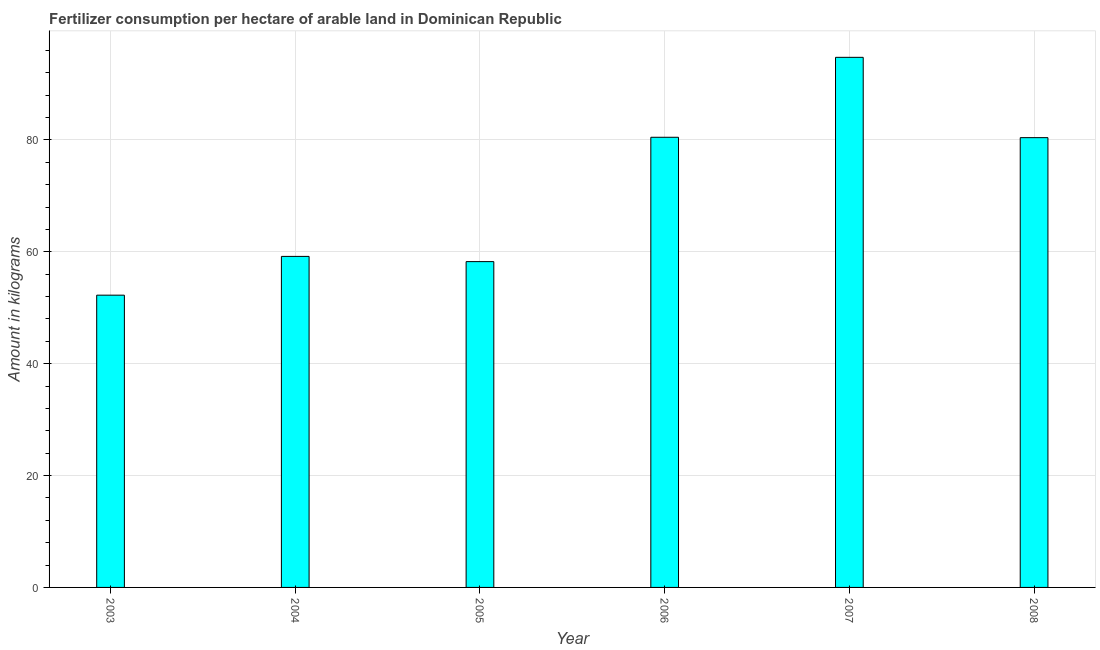What is the title of the graph?
Give a very brief answer. Fertilizer consumption per hectare of arable land in Dominican Republic . What is the label or title of the Y-axis?
Keep it short and to the point. Amount in kilograms. What is the amount of fertilizer consumption in 2008?
Provide a succinct answer. 80.4. Across all years, what is the maximum amount of fertilizer consumption?
Offer a very short reply. 94.76. Across all years, what is the minimum amount of fertilizer consumption?
Your answer should be compact. 52.24. In which year was the amount of fertilizer consumption maximum?
Keep it short and to the point. 2007. In which year was the amount of fertilizer consumption minimum?
Offer a terse response. 2003. What is the sum of the amount of fertilizer consumption?
Offer a terse response. 425.28. What is the difference between the amount of fertilizer consumption in 2007 and 2008?
Your response must be concise. 14.36. What is the average amount of fertilizer consumption per year?
Ensure brevity in your answer.  70.88. What is the median amount of fertilizer consumption?
Your answer should be very brief. 69.79. In how many years, is the amount of fertilizer consumption greater than 36 kg?
Make the answer very short. 6. What is the ratio of the amount of fertilizer consumption in 2005 to that in 2006?
Your answer should be compact. 0.72. Is the amount of fertilizer consumption in 2006 less than that in 2008?
Make the answer very short. No. What is the difference between the highest and the second highest amount of fertilizer consumption?
Your answer should be very brief. 14.29. Is the sum of the amount of fertilizer consumption in 2003 and 2008 greater than the maximum amount of fertilizer consumption across all years?
Ensure brevity in your answer.  Yes. What is the difference between the highest and the lowest amount of fertilizer consumption?
Your response must be concise. 42.51. Are all the bars in the graph horizontal?
Keep it short and to the point. No. Are the values on the major ticks of Y-axis written in scientific E-notation?
Your response must be concise. No. What is the Amount in kilograms of 2003?
Offer a terse response. 52.24. What is the Amount in kilograms in 2004?
Keep it short and to the point. 59.17. What is the Amount in kilograms in 2005?
Give a very brief answer. 58.24. What is the Amount in kilograms of 2006?
Keep it short and to the point. 80.47. What is the Amount in kilograms in 2007?
Give a very brief answer. 94.76. What is the Amount in kilograms in 2008?
Provide a short and direct response. 80.4. What is the difference between the Amount in kilograms in 2003 and 2004?
Keep it short and to the point. -6.93. What is the difference between the Amount in kilograms in 2003 and 2005?
Your answer should be very brief. -6. What is the difference between the Amount in kilograms in 2003 and 2006?
Ensure brevity in your answer.  -28.22. What is the difference between the Amount in kilograms in 2003 and 2007?
Offer a very short reply. -42.51. What is the difference between the Amount in kilograms in 2003 and 2008?
Your answer should be very brief. -28.16. What is the difference between the Amount in kilograms in 2004 and 2005?
Give a very brief answer. 0.93. What is the difference between the Amount in kilograms in 2004 and 2006?
Your response must be concise. -21.29. What is the difference between the Amount in kilograms in 2004 and 2007?
Make the answer very short. -35.58. What is the difference between the Amount in kilograms in 2004 and 2008?
Provide a short and direct response. -21.23. What is the difference between the Amount in kilograms in 2005 and 2006?
Offer a very short reply. -22.23. What is the difference between the Amount in kilograms in 2005 and 2007?
Give a very brief answer. -36.52. What is the difference between the Amount in kilograms in 2005 and 2008?
Offer a very short reply. -22.16. What is the difference between the Amount in kilograms in 2006 and 2007?
Your response must be concise. -14.29. What is the difference between the Amount in kilograms in 2006 and 2008?
Your response must be concise. 0.07. What is the difference between the Amount in kilograms in 2007 and 2008?
Give a very brief answer. 14.36. What is the ratio of the Amount in kilograms in 2003 to that in 2004?
Keep it short and to the point. 0.88. What is the ratio of the Amount in kilograms in 2003 to that in 2005?
Make the answer very short. 0.9. What is the ratio of the Amount in kilograms in 2003 to that in 2006?
Provide a succinct answer. 0.65. What is the ratio of the Amount in kilograms in 2003 to that in 2007?
Make the answer very short. 0.55. What is the ratio of the Amount in kilograms in 2003 to that in 2008?
Offer a terse response. 0.65. What is the ratio of the Amount in kilograms in 2004 to that in 2006?
Keep it short and to the point. 0.73. What is the ratio of the Amount in kilograms in 2004 to that in 2007?
Make the answer very short. 0.62. What is the ratio of the Amount in kilograms in 2004 to that in 2008?
Offer a very short reply. 0.74. What is the ratio of the Amount in kilograms in 2005 to that in 2006?
Give a very brief answer. 0.72. What is the ratio of the Amount in kilograms in 2005 to that in 2007?
Give a very brief answer. 0.61. What is the ratio of the Amount in kilograms in 2005 to that in 2008?
Provide a succinct answer. 0.72. What is the ratio of the Amount in kilograms in 2006 to that in 2007?
Ensure brevity in your answer.  0.85. What is the ratio of the Amount in kilograms in 2007 to that in 2008?
Make the answer very short. 1.18. 